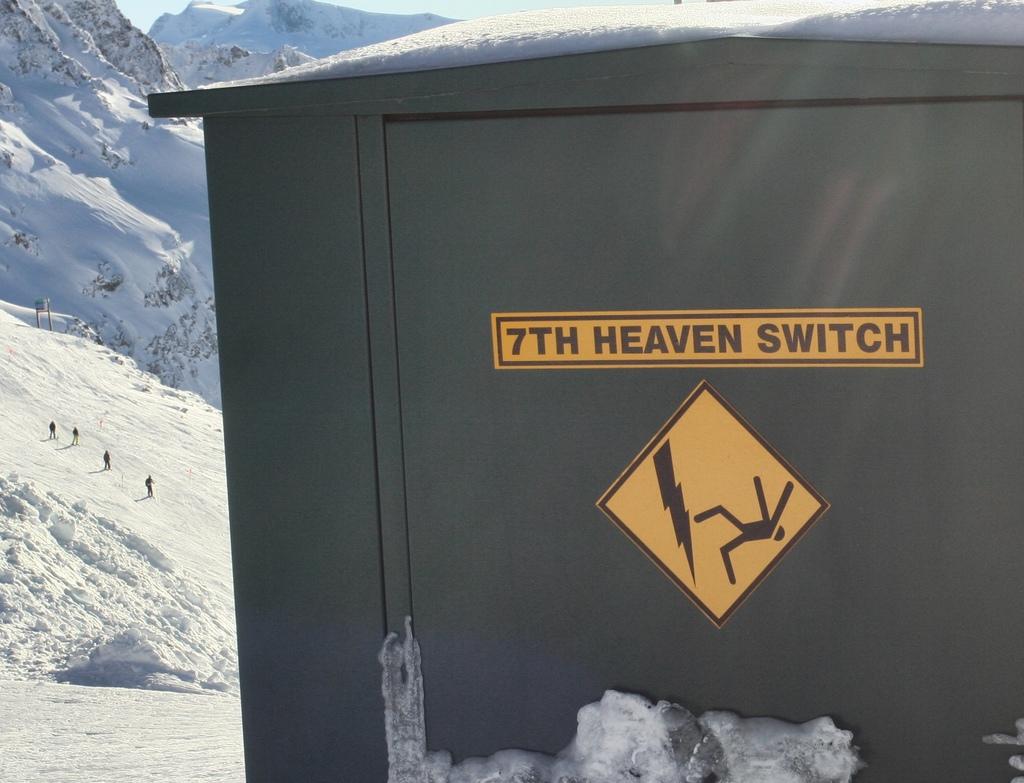What does the yellow sing on the bin say?
Keep it short and to the point. 7th heaven switch. 